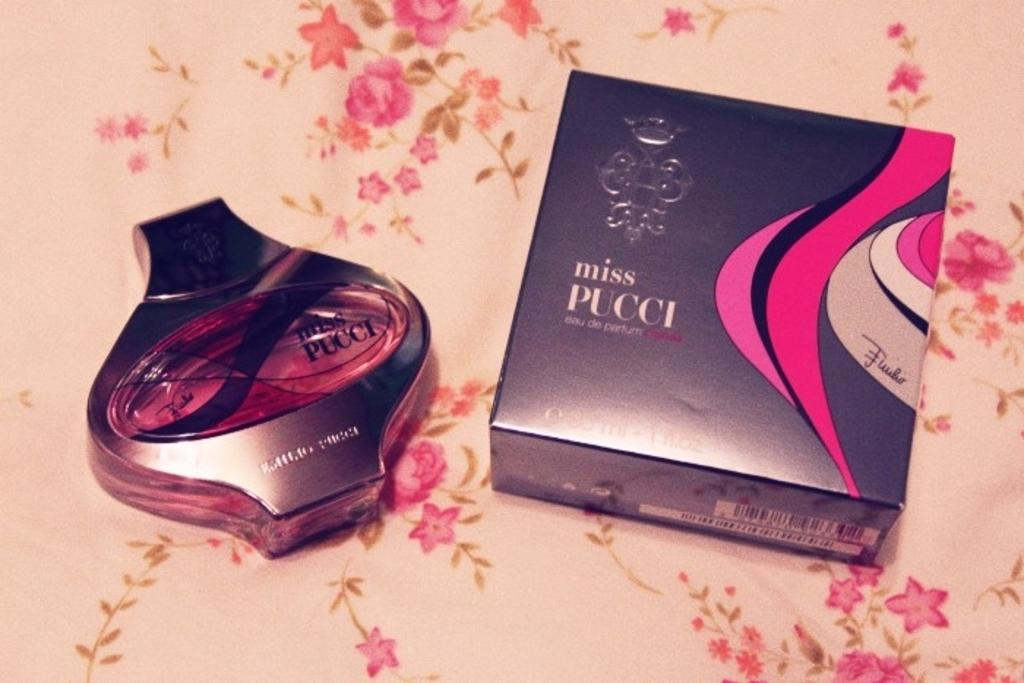<image>
Write a terse but informative summary of the picture. A bottle of Miss Pucci perfume is placed next to its box. 